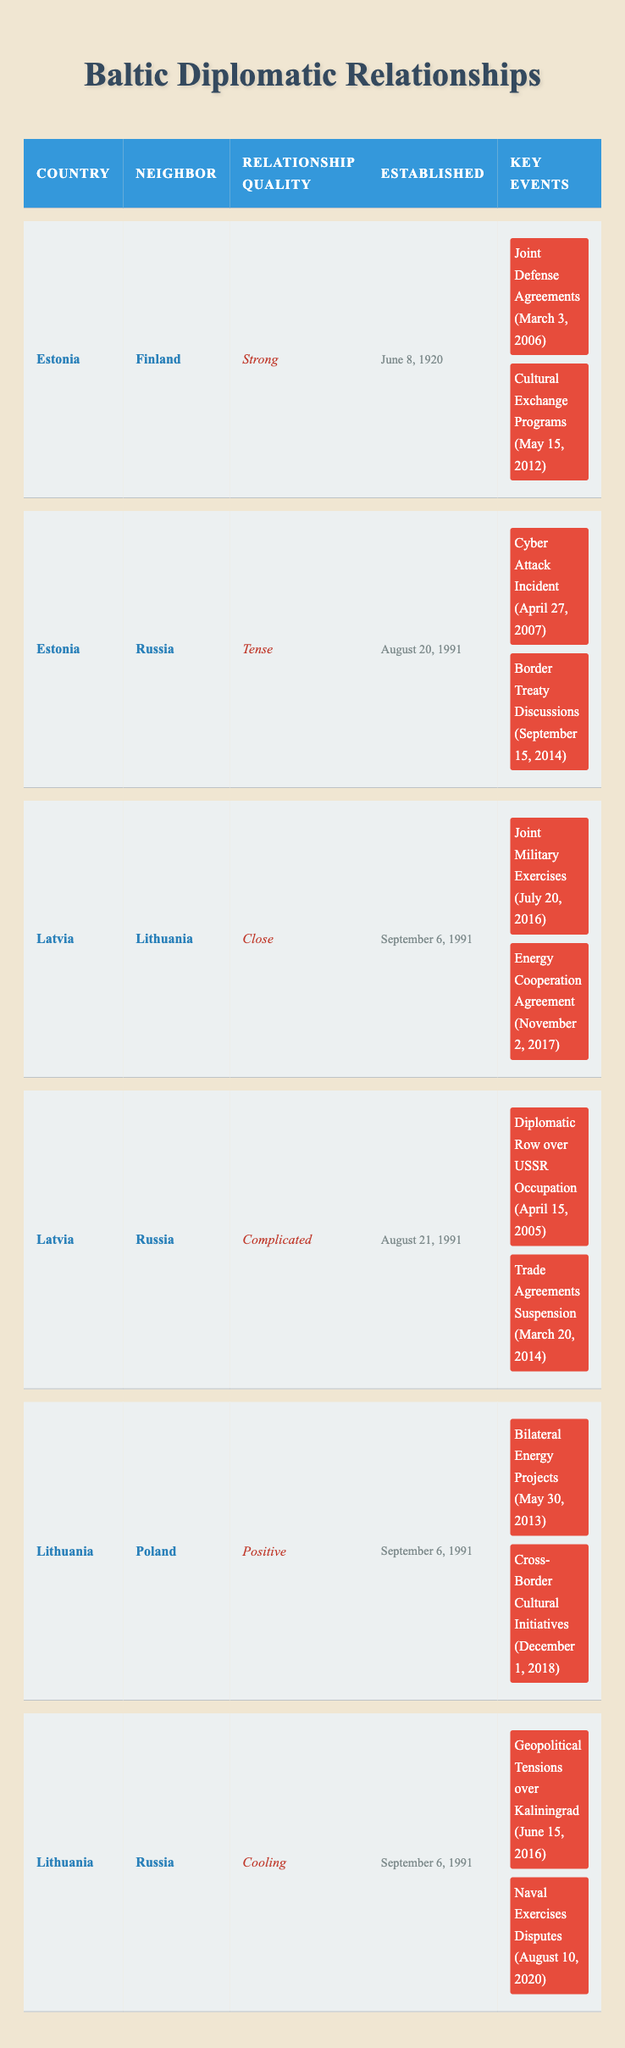What is the relationship quality between Estonia and Finland? The table explicitly states that the relationship quality between Estonia and Finland is "Strong."
Answer: Strong When was the diplomatic relationship between Latvia and Russia established? The table indicates that Latvia established diplomatic relations with Russia on August 21, 1991.
Answer: August 21, 1991 Which country has a complicated relationship with Latvia? The data shows that Russia has a complicated relationship with Latvia, as noted in the relationship quality column.
Answer: Russia How many key events are listed for the diplomatic relationship between Lithuania and Poland? The table lists two key events for Lithuania and Poland: "Bilateral Energy Projects" and "Cross-Border Cultural Initiatives."
Answer: 2 What was the date of the Cyber Attack Incident involving Estonia and Russia? According to the information provided in the table, the Cyber Attack Incident occurred on April 27, 2007.
Answer: April 27, 2007 Is the relationship between Estonia and Russia tense? The relationship quality section of the table clearly specifies that the relationship between Estonia and Russia is "Tense."
Answer: Yes Which neighboring country of Latvia has a close relationship? The table indicates that Lithuania is the neighboring country of Latvia with a "Close" relationship as established on September 6, 1991.
Answer: Lithuania What event marked the diplomatic row involving Latvia? The table provides the event titled "Diplomatic Row over USSR Occupation," which occurred on April 15, 2005.
Answer: Diplomatic Row over USSR Occupation What is the main reason for the cooling relationship between Lithuania and Russia? The table suggests that geopolitical tensions over Kaliningrad and disputes during naval exercises are key reasons for the cooling relationship with Russia.
Answer: Geopolitical tensions over Kaliningrad How many total key events are listed for the relationship between Estonia and Russia? The total number of key events listed for Estonia and Russia is two: "Cyber Attack Incident" and "Border Treaty Discussions."
Answer: 2 